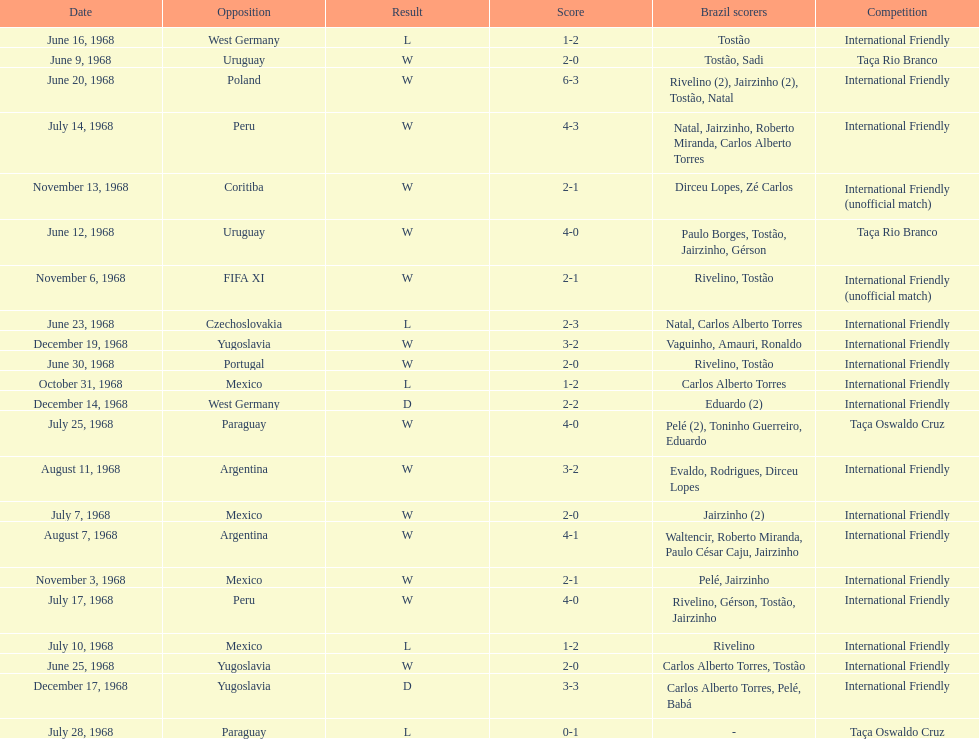Can you parse all the data within this table? {'header': ['Date', 'Opposition', 'Result', 'Score', 'Brazil scorers', 'Competition'], 'rows': [['June 16, 1968', 'West Germany', 'L', '1-2', 'Tostão', 'International Friendly'], ['June 9, 1968', 'Uruguay', 'W', '2-0', 'Tostão, Sadi', 'Taça Rio Branco'], ['June 20, 1968', 'Poland', 'W', '6-3', 'Rivelino (2), Jairzinho (2), Tostão, Natal', 'International Friendly'], ['July 14, 1968', 'Peru', 'W', '4-3', 'Natal, Jairzinho, Roberto Miranda, Carlos Alberto Torres', 'International Friendly'], ['November 13, 1968', 'Coritiba', 'W', '2-1', 'Dirceu Lopes, Zé Carlos', 'International Friendly (unofficial match)'], ['June 12, 1968', 'Uruguay', 'W', '4-0', 'Paulo Borges, Tostão, Jairzinho, Gérson', 'Taça Rio Branco'], ['November 6, 1968', 'FIFA XI', 'W', '2-1', 'Rivelino, Tostão', 'International Friendly (unofficial match)'], ['June 23, 1968', 'Czechoslovakia', 'L', '2-3', 'Natal, Carlos Alberto Torres', 'International Friendly'], ['December 19, 1968', 'Yugoslavia', 'W', '3-2', 'Vaguinho, Amauri, Ronaldo', 'International Friendly'], ['June 30, 1968', 'Portugal', 'W', '2-0', 'Rivelino, Tostão', 'International Friendly'], ['October 31, 1968', 'Mexico', 'L', '1-2', 'Carlos Alberto Torres', 'International Friendly'], ['December 14, 1968', 'West Germany', 'D', '2-2', 'Eduardo (2)', 'International Friendly'], ['July 25, 1968', 'Paraguay', 'W', '4-0', 'Pelé (2), Toninho Guerreiro, Eduardo', 'Taça Oswaldo Cruz'], ['August 11, 1968', 'Argentina', 'W', '3-2', 'Evaldo, Rodrigues, Dirceu Lopes', 'International Friendly'], ['July 7, 1968', 'Mexico', 'W', '2-0', 'Jairzinho (2)', 'International Friendly'], ['August 7, 1968', 'Argentina', 'W', '4-1', 'Waltencir, Roberto Miranda, Paulo César Caju, Jairzinho', 'International Friendly'], ['November 3, 1968', 'Mexico', 'W', '2-1', 'Pelé, Jairzinho', 'International Friendly'], ['July 17, 1968', 'Peru', 'W', '4-0', 'Rivelino, Gérson, Tostão, Jairzinho', 'International Friendly'], ['July 10, 1968', 'Mexico', 'L', '1-2', 'Rivelino', 'International Friendly'], ['June 25, 1968', 'Yugoslavia', 'W', '2-0', 'Carlos Alberto Torres, Tostão', 'International Friendly'], ['December 17, 1968', 'Yugoslavia', 'D', '3-3', 'Carlos Alberto Torres, Pelé, Babá', 'International Friendly'], ['July 28, 1968', 'Paraguay', 'L', '0-1', '-', 'Taça Oswaldo Cruz']]} What year has the highest scoring game? 1968. 